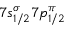<formula> <loc_0><loc_0><loc_500><loc_500>7 s _ { 1 / 2 } ^ { \sigma } 7 p _ { 1 / 2 } ^ { \pi }</formula> 